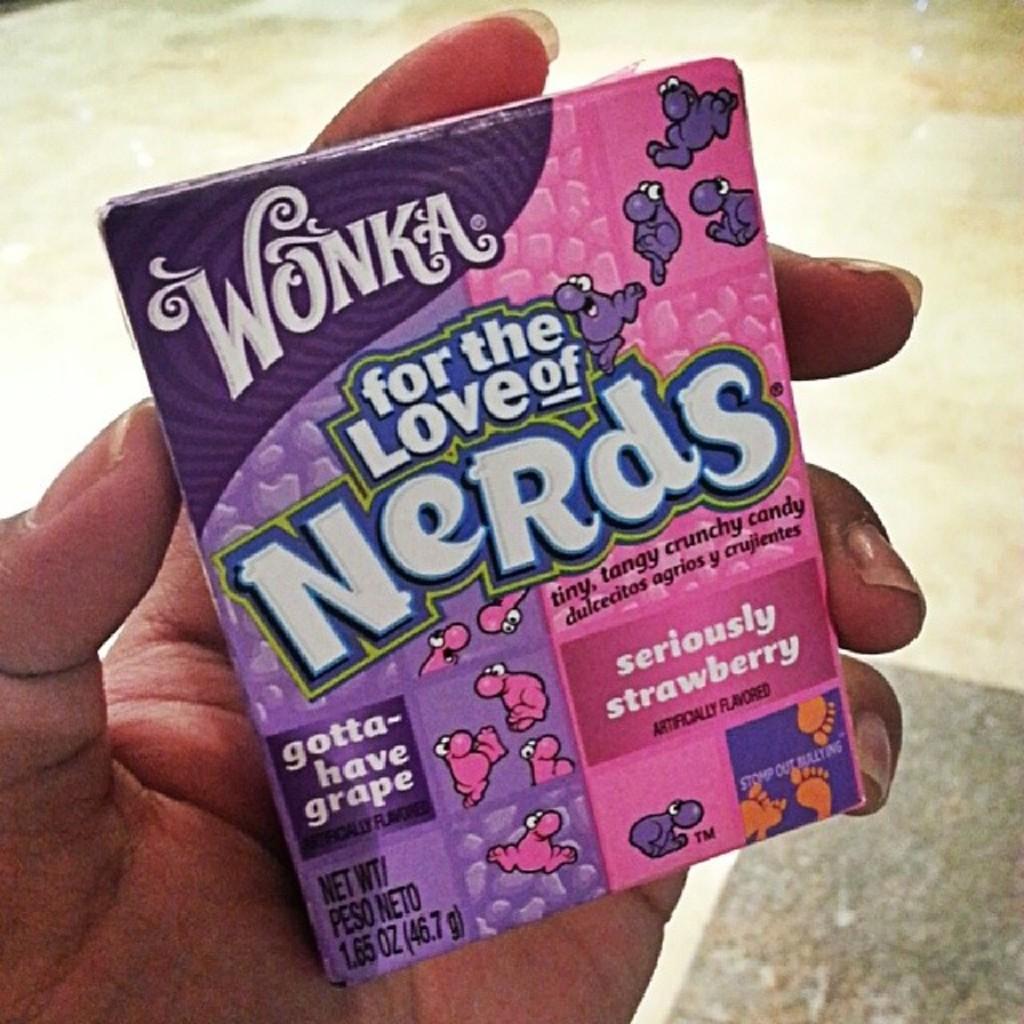How would you summarize this image in a sentence or two? In the center of the image we can see one human hand holding one object. On the object, we can see some text. In the background we can see the floor. 